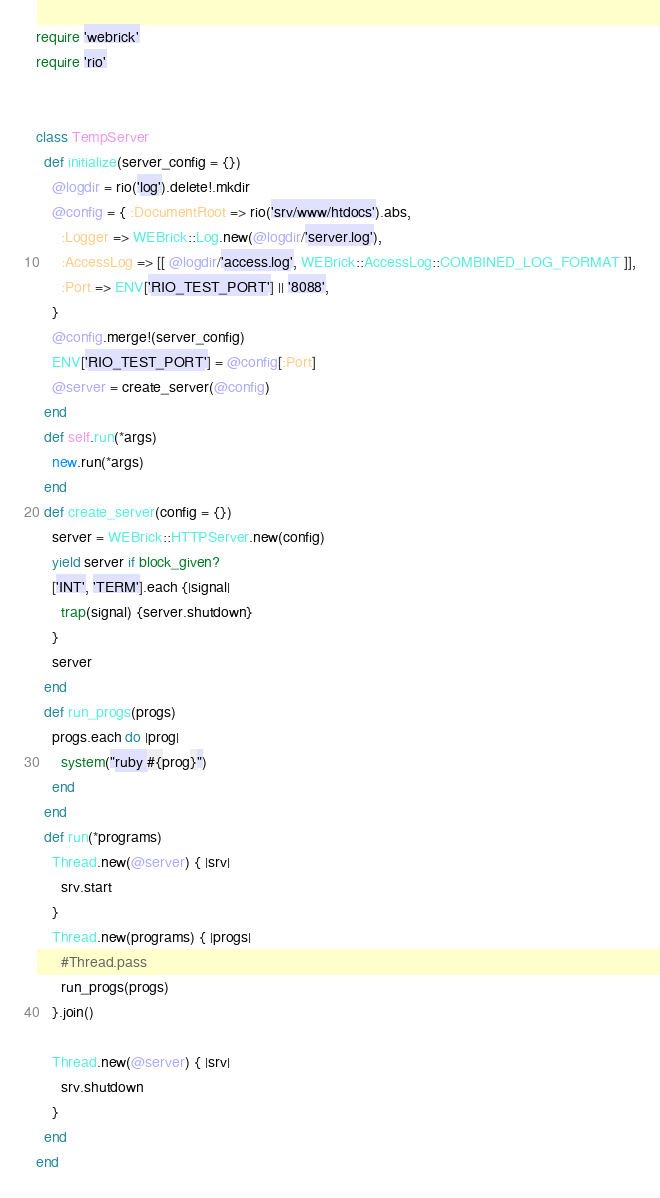Convert code to text. <code><loc_0><loc_0><loc_500><loc_500><_Ruby_>require 'webrick'
require 'rio'


class TempServer
  def initialize(server_config = {})
    @logdir = rio('log').delete!.mkdir
    @config = { :DocumentRoot => rio('srv/www/htdocs').abs, 
      :Logger => WEBrick::Log.new(@logdir/'server.log'), 
      :AccessLog => [[ @logdir/'access.log', WEBrick::AccessLog::COMBINED_LOG_FORMAT ]],
      :Port => ENV['RIO_TEST_PORT'] || '8088',
    }
    @config.merge!(server_config)
    ENV['RIO_TEST_PORT'] = @config[:Port]
    @server = create_server(@config)
  end
  def self.run(*args)
    new.run(*args)
  end
  def create_server(config = {})
    server = WEBrick::HTTPServer.new(config)
    yield server if block_given?
    ['INT', 'TERM'].each {|signal| 
      trap(signal) {server.shutdown}
    }
    server
  end
  def run_progs(progs)
    progs.each do |prog|
      system("ruby #{prog}")
    end
  end
  def run(*programs)
    Thread.new(@server) { |srv|
      srv.start
    }
    Thread.new(programs) { |progs|
      #Thread.pass
      run_progs(progs)
    }.join()
    
    Thread.new(@server) { |srv|
      srv.shutdown
    }
  end
end
</code> 